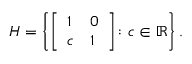Convert formula to latex. <formula><loc_0><loc_0><loc_500><loc_500>H = \left \{ { \left [ \begin{array} { l l } { 1 } & { 0 } \\ { c } & { 1 } \end{array} \right ] } \colon c \in \mathbb { R } \right \} .</formula> 